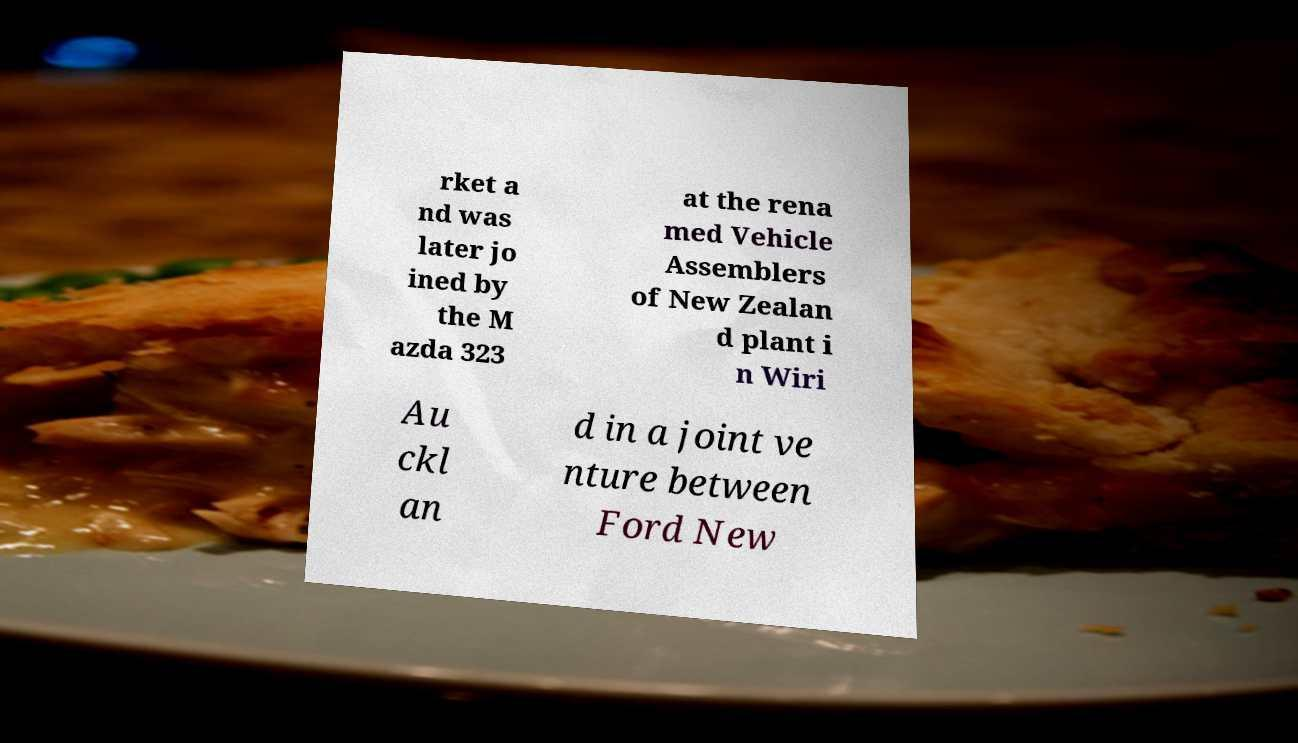Please identify and transcribe the text found in this image. rket a nd was later jo ined by the M azda 323 at the rena med Vehicle Assemblers of New Zealan d plant i n Wiri Au ckl an d in a joint ve nture between Ford New 